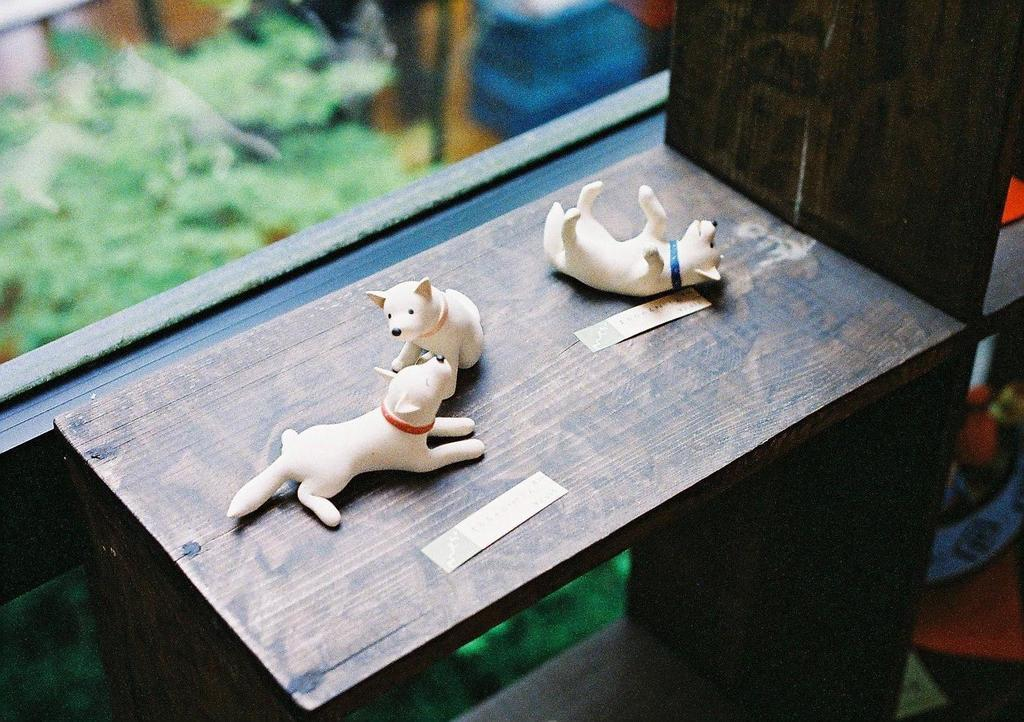How many toys are present on the wooden shelf in the image? There are three toys on the wooden shelf in the image. What is located beside the wooden shelf? There is a window beside the wooden shelf. Is there an alarm sounding in the image? There is no indication of an alarm in the image. What type of battle is taking place in the image? There is no battle present in the image. 